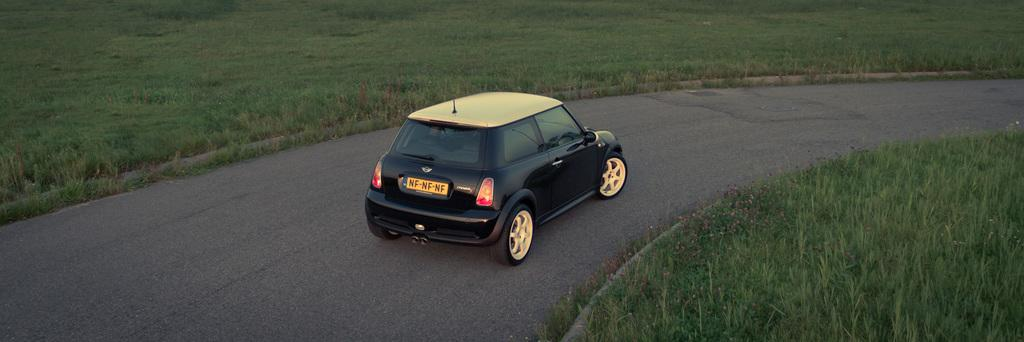What is the main subject of the image? The main subject of the image is a car on the road. What type of vegetation can be seen in the image? There is grass visible in the image. What type of pollution is visible in the image? There is no visible pollution in the image. What type of school can be seen in the image? There is no school present in the image. 